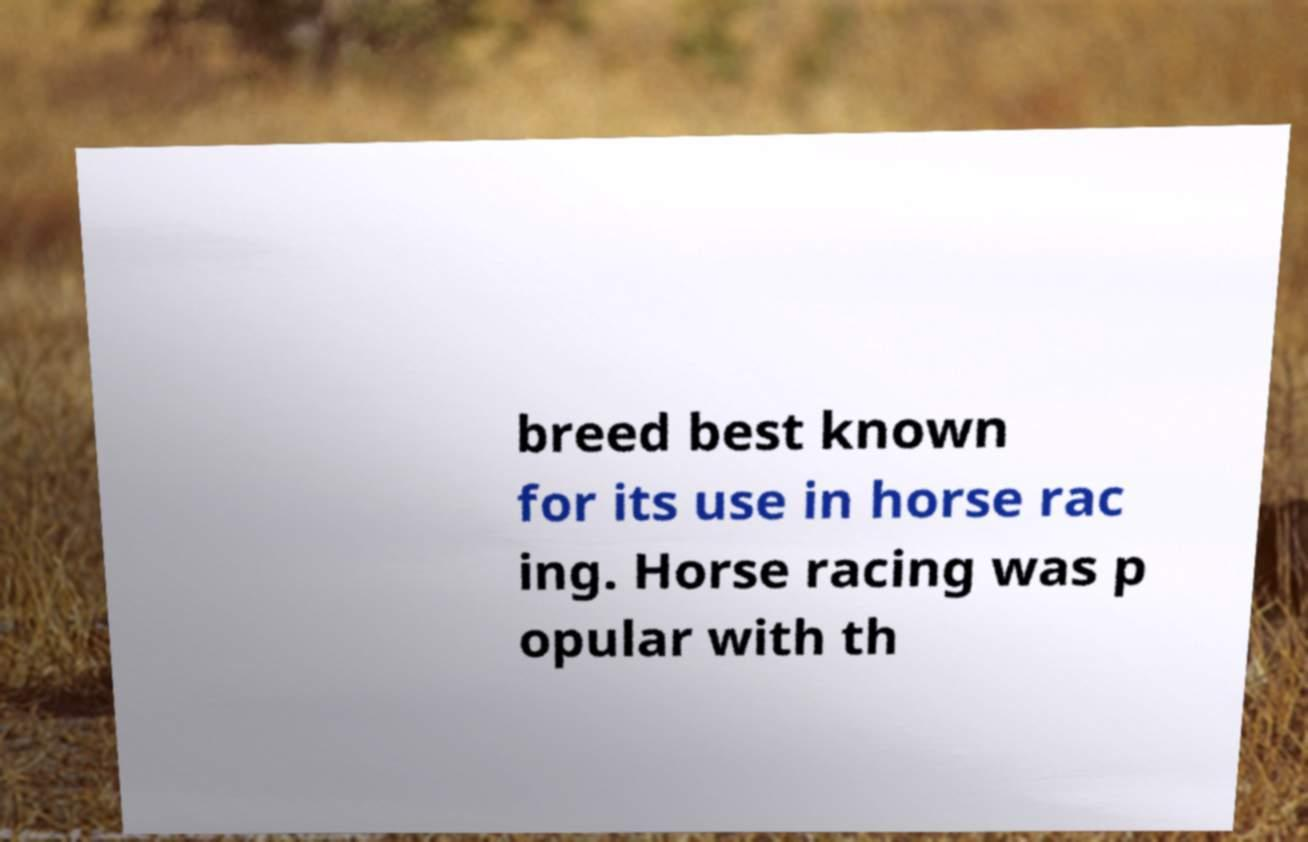Could you extract and type out the text from this image? breed best known for its use in horse rac ing. Horse racing was p opular with th 